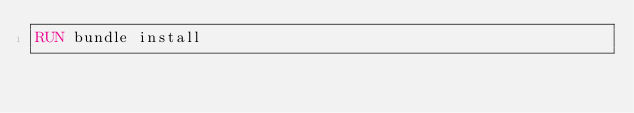<code> <loc_0><loc_0><loc_500><loc_500><_Dockerfile_>RUN bundle install
</code> 